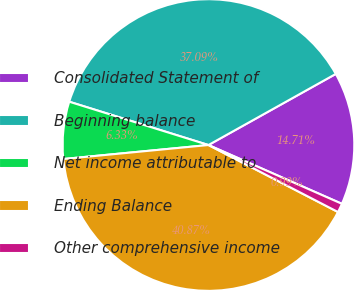Convert chart. <chart><loc_0><loc_0><loc_500><loc_500><pie_chart><fcel>Consolidated Statement of<fcel>Beginning balance<fcel>Net income attributable to<fcel>Ending Balance<fcel>Other comprehensive income<nl><fcel>14.71%<fcel>37.09%<fcel>6.33%<fcel>40.87%<fcel>0.99%<nl></chart> 